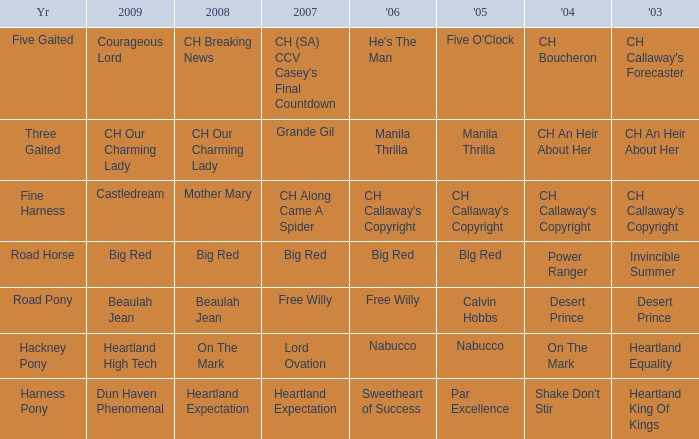What year is the 2007 big red? Road Horse. 